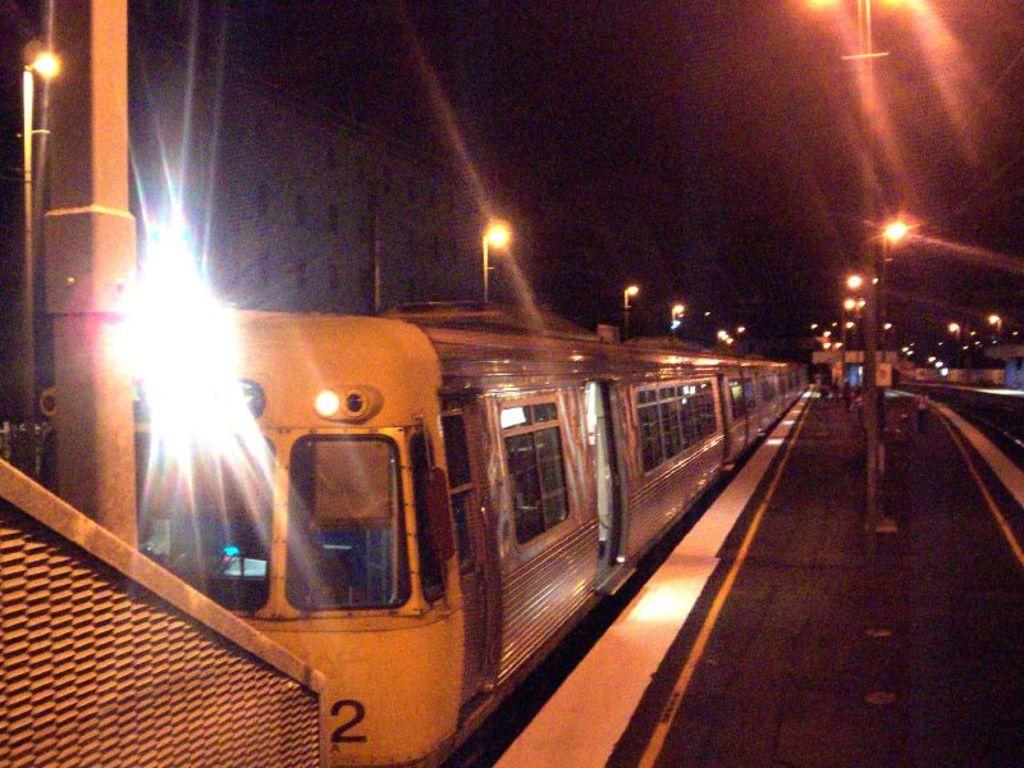What number is visible on the front of the train car?
Provide a short and direct response. 2. 